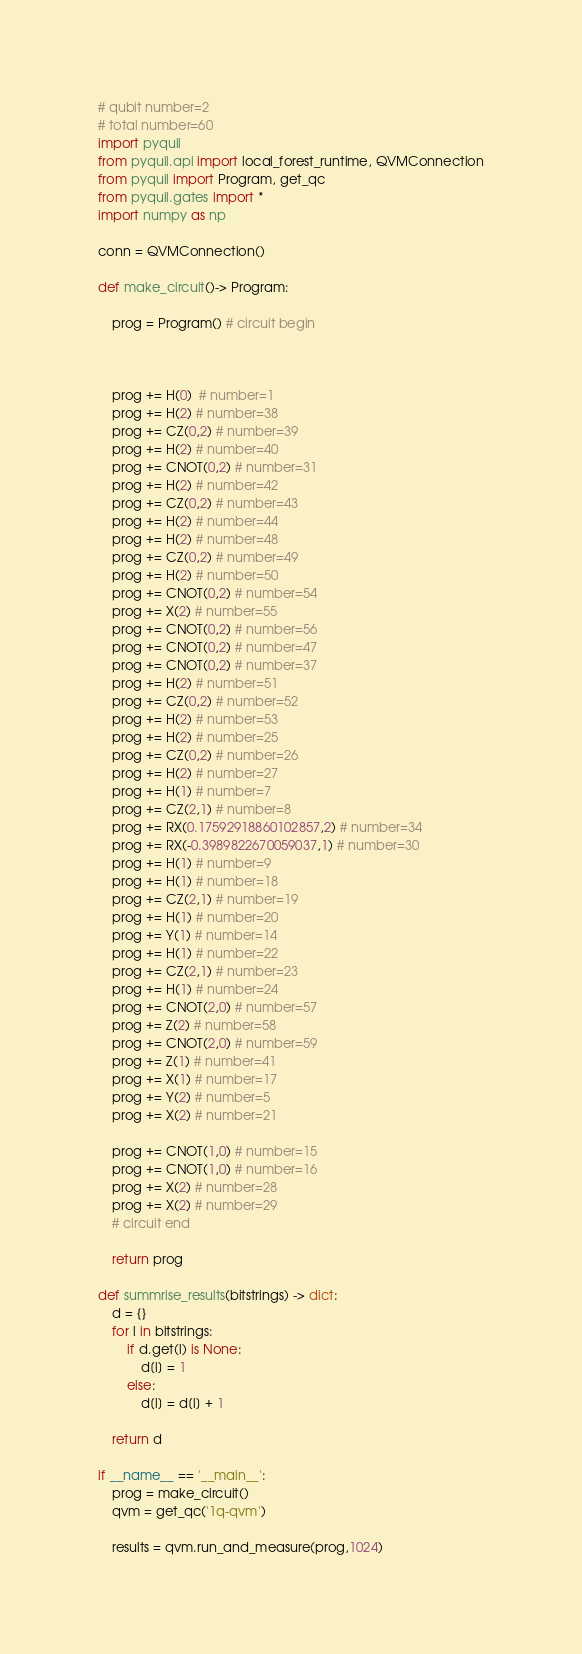Convert code to text. <code><loc_0><loc_0><loc_500><loc_500><_Python_># qubit number=2
# total number=60
import pyquil
from pyquil.api import local_forest_runtime, QVMConnection
from pyquil import Program, get_qc
from pyquil.gates import *
import numpy as np

conn = QVMConnection()

def make_circuit()-> Program:

    prog = Program() # circuit begin



    prog += H(0)  # number=1
    prog += H(2) # number=38
    prog += CZ(0,2) # number=39
    prog += H(2) # number=40
    prog += CNOT(0,2) # number=31
    prog += H(2) # number=42
    prog += CZ(0,2) # number=43
    prog += H(2) # number=44
    prog += H(2) # number=48
    prog += CZ(0,2) # number=49
    prog += H(2) # number=50
    prog += CNOT(0,2) # number=54
    prog += X(2) # number=55
    prog += CNOT(0,2) # number=56
    prog += CNOT(0,2) # number=47
    prog += CNOT(0,2) # number=37
    prog += H(2) # number=51
    prog += CZ(0,2) # number=52
    prog += H(2) # number=53
    prog += H(2) # number=25
    prog += CZ(0,2) # number=26
    prog += H(2) # number=27
    prog += H(1) # number=7
    prog += CZ(2,1) # number=8
    prog += RX(0.17592918860102857,2) # number=34
    prog += RX(-0.3989822670059037,1) # number=30
    prog += H(1) # number=9
    prog += H(1) # number=18
    prog += CZ(2,1) # number=19
    prog += H(1) # number=20
    prog += Y(1) # number=14
    prog += H(1) # number=22
    prog += CZ(2,1) # number=23
    prog += H(1) # number=24
    prog += CNOT(2,0) # number=57
    prog += Z(2) # number=58
    prog += CNOT(2,0) # number=59
    prog += Z(1) # number=41
    prog += X(1) # number=17
    prog += Y(2) # number=5
    prog += X(2) # number=21

    prog += CNOT(1,0) # number=15
    prog += CNOT(1,0) # number=16
    prog += X(2) # number=28
    prog += X(2) # number=29
    # circuit end

    return prog

def summrise_results(bitstrings) -> dict:
    d = {}
    for l in bitstrings:
        if d.get(l) is None:
            d[l] = 1
        else:
            d[l] = d[l] + 1

    return d

if __name__ == '__main__':
    prog = make_circuit()
    qvm = get_qc('1q-qvm')

    results = qvm.run_and_measure(prog,1024)</code> 